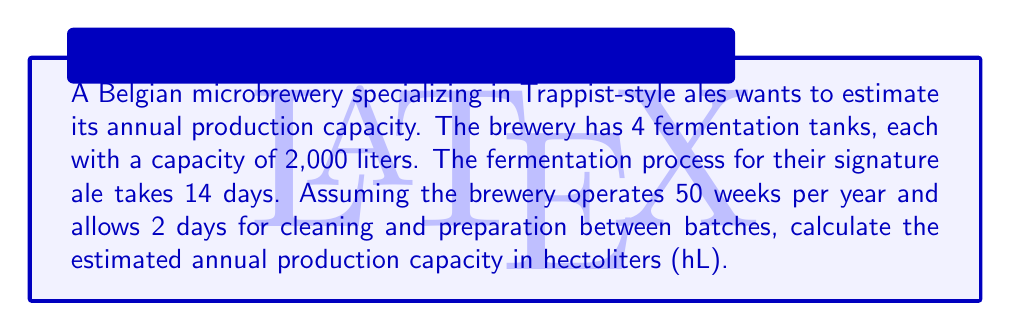Could you help me with this problem? Let's break this problem down step-by-step:

1. Calculate the number of batches per tank per year:
   - Days in 50 weeks: $50 \times 7 = 350$ days
   - Time for one batch: $14 \text{ (fermentation)} + 2 \text{ (cleaning)} = 16$ days
   - Batches per tank per year: $\frac{350 \text{ days}}{16 \text{ days/batch}} = 21.875$ batches

2. Calculate the total number of batches per year for all tanks:
   - Number of tanks: 4
   - Total batches per year: $21.875 \times 4 = 87.5$ batches

3. Calculate the total production volume:
   - Volume per batch: 2,000 liters
   - Total annual volume: $87.5 \times 2,000 = 175,000$ liters

4. Convert liters to hectoliters:
   - 1 hectoliter = 100 liters
   - Annual production in hL: $\frac{175,000 \text{ liters}}{100 \text{ liters/hL}} = 1,750$ hL

Therefore, the estimated annual production capacity is 1,750 hL.
Answer: 1,750 hL 